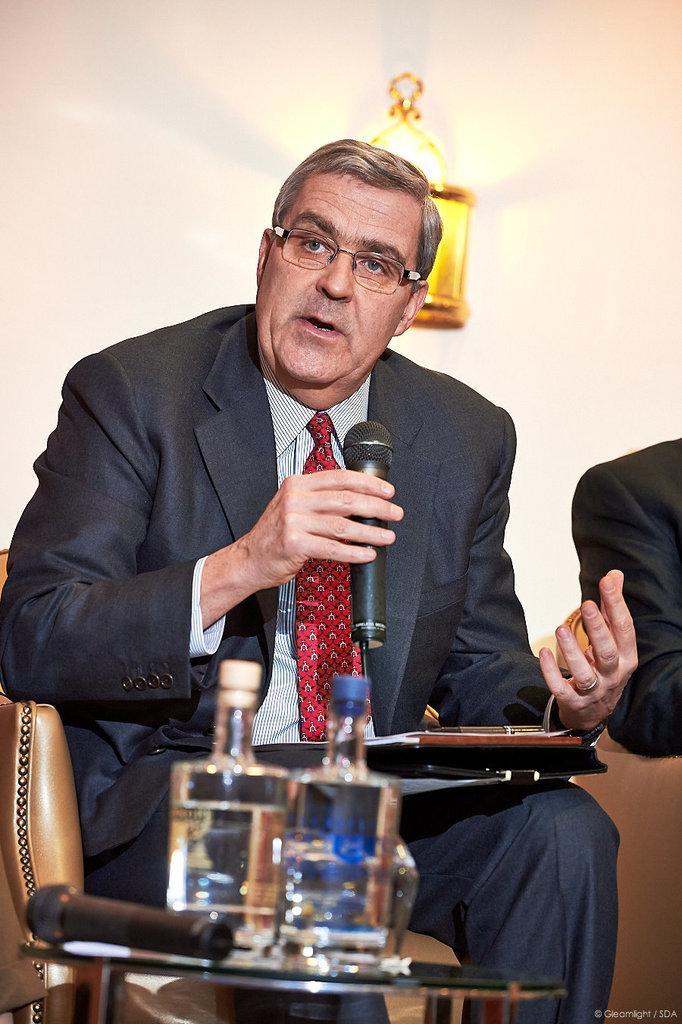In one or two sentences, can you explain what this image depicts? In this picture a man is seated on the chair and he is talking with the help of microphone, in front of him we can see bottles, microphone on the table, in the background we can see a light. 